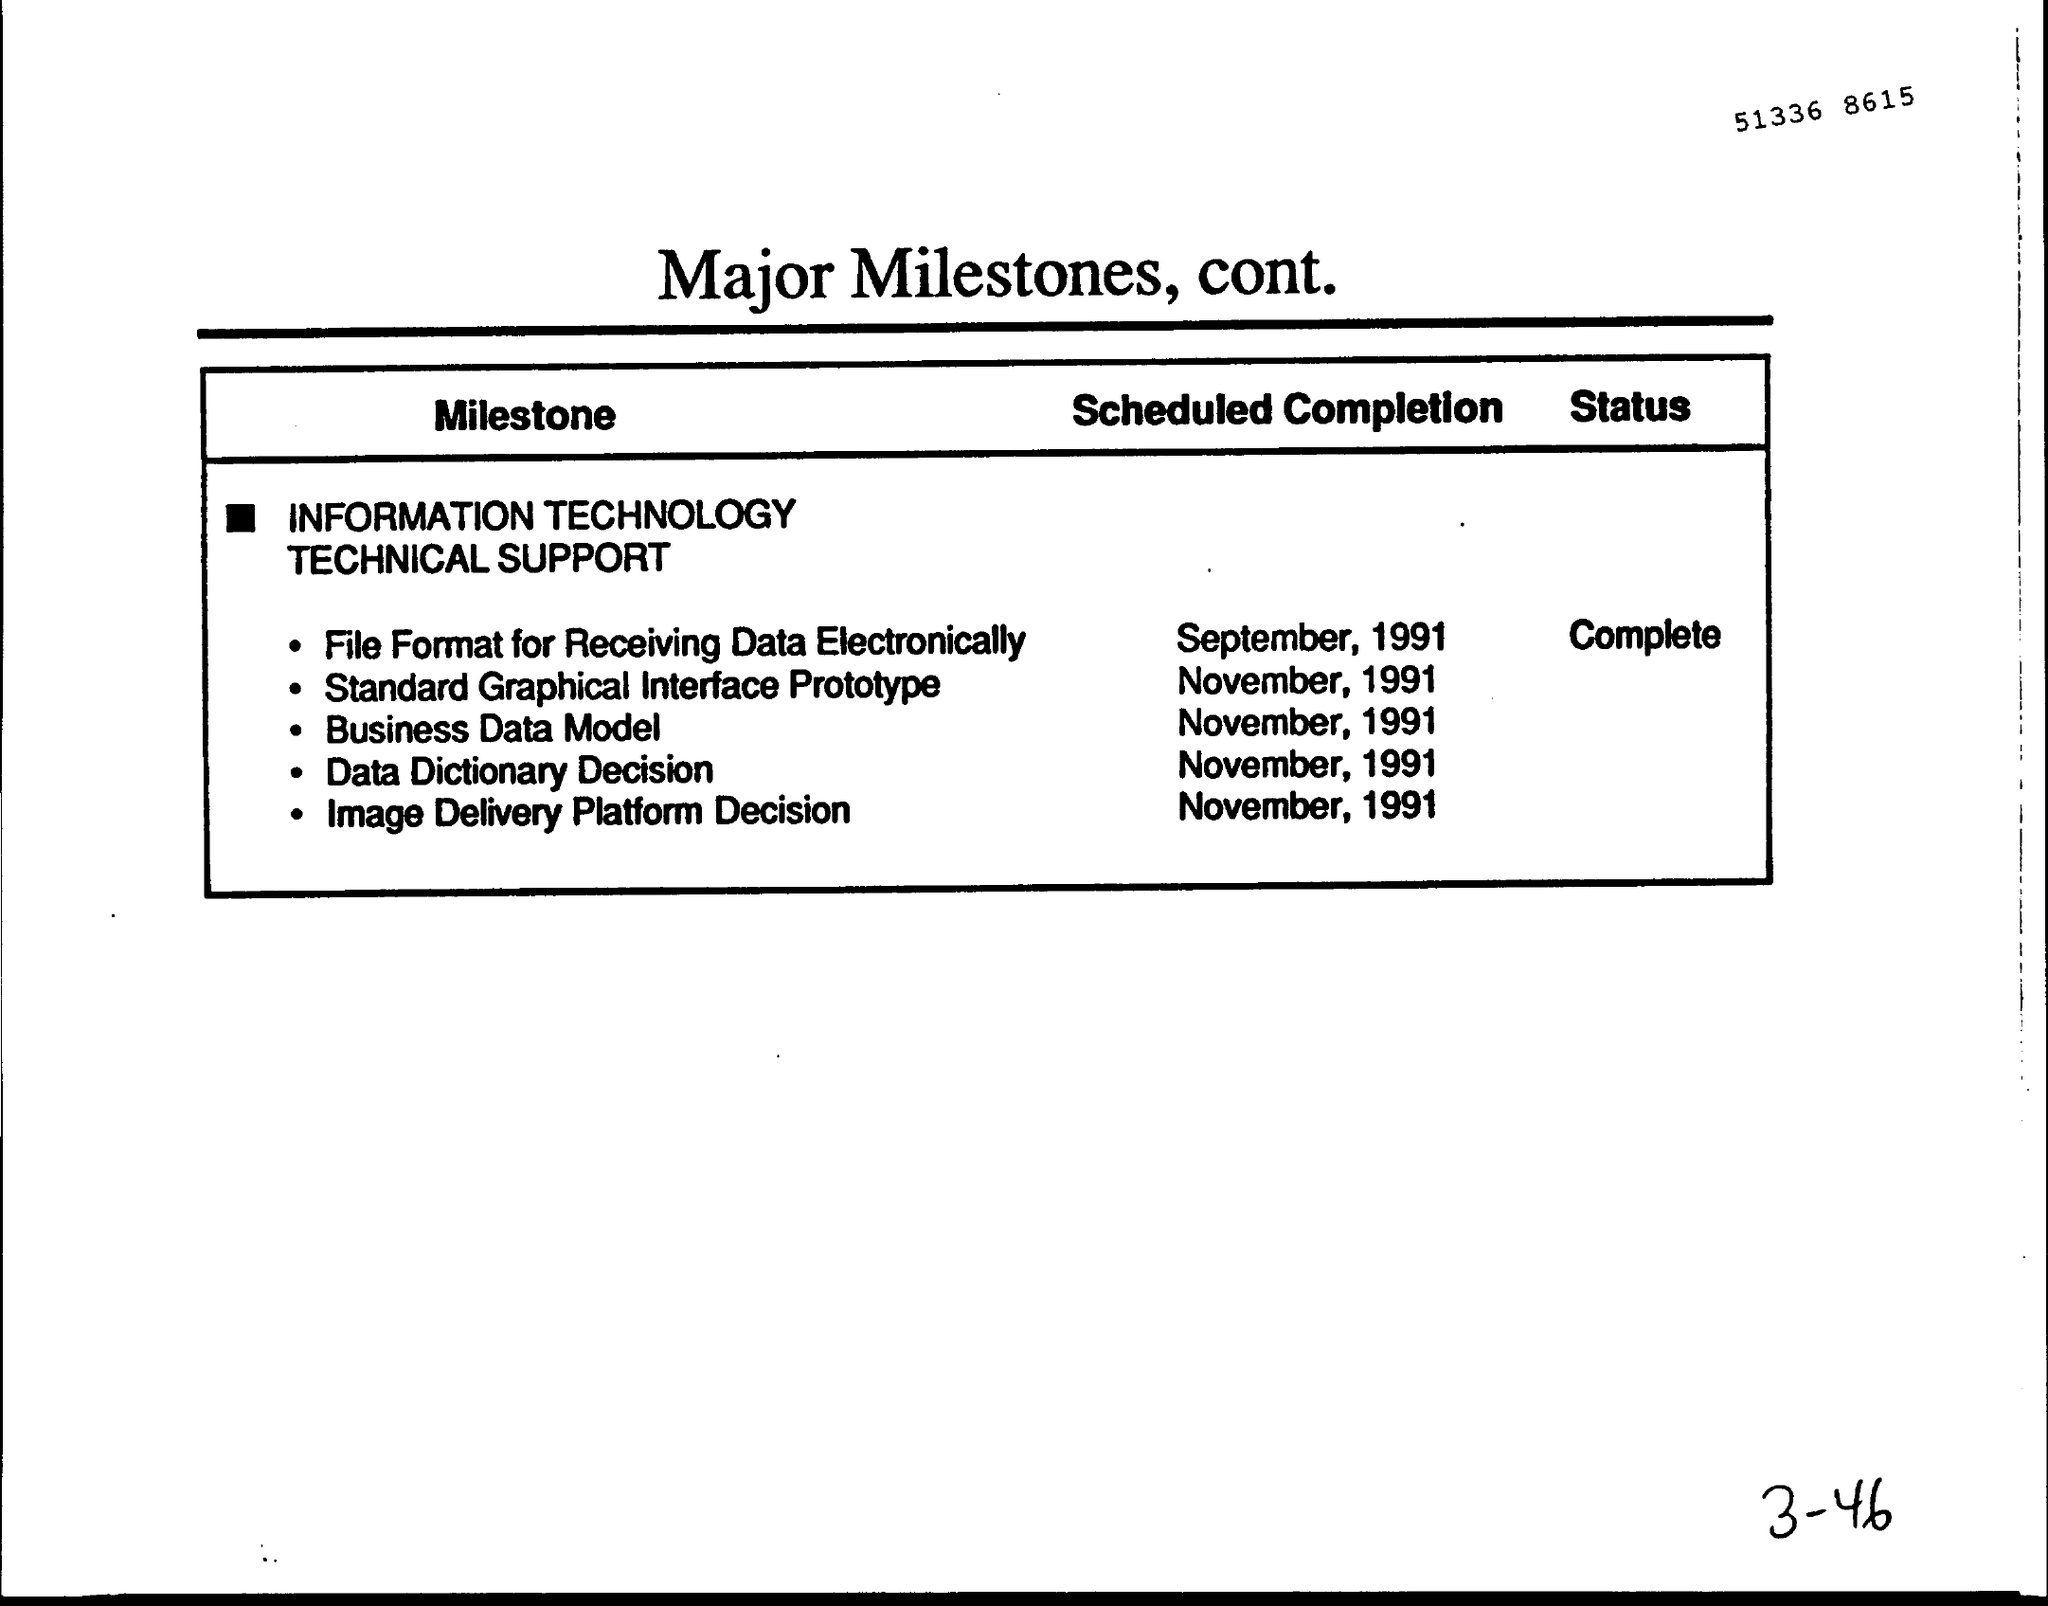What is the Title of the document?
Provide a short and direct response. Major Milestones, cont. What is the "Scheduled Completion" for "Business Data Model"?
Give a very brief answer. November, 1991. What is the "Scheduled Completion" for "Data dictionary Decision"?
Offer a terse response. November, 1991. What is the "Scheduled Completion" for "Image Delivery Platform Decision"?
Ensure brevity in your answer.  November, 1991. What is the "Scheduled Completion" for "Standard Graphical Interface Prototype"?
Make the answer very short. November, 1991. 